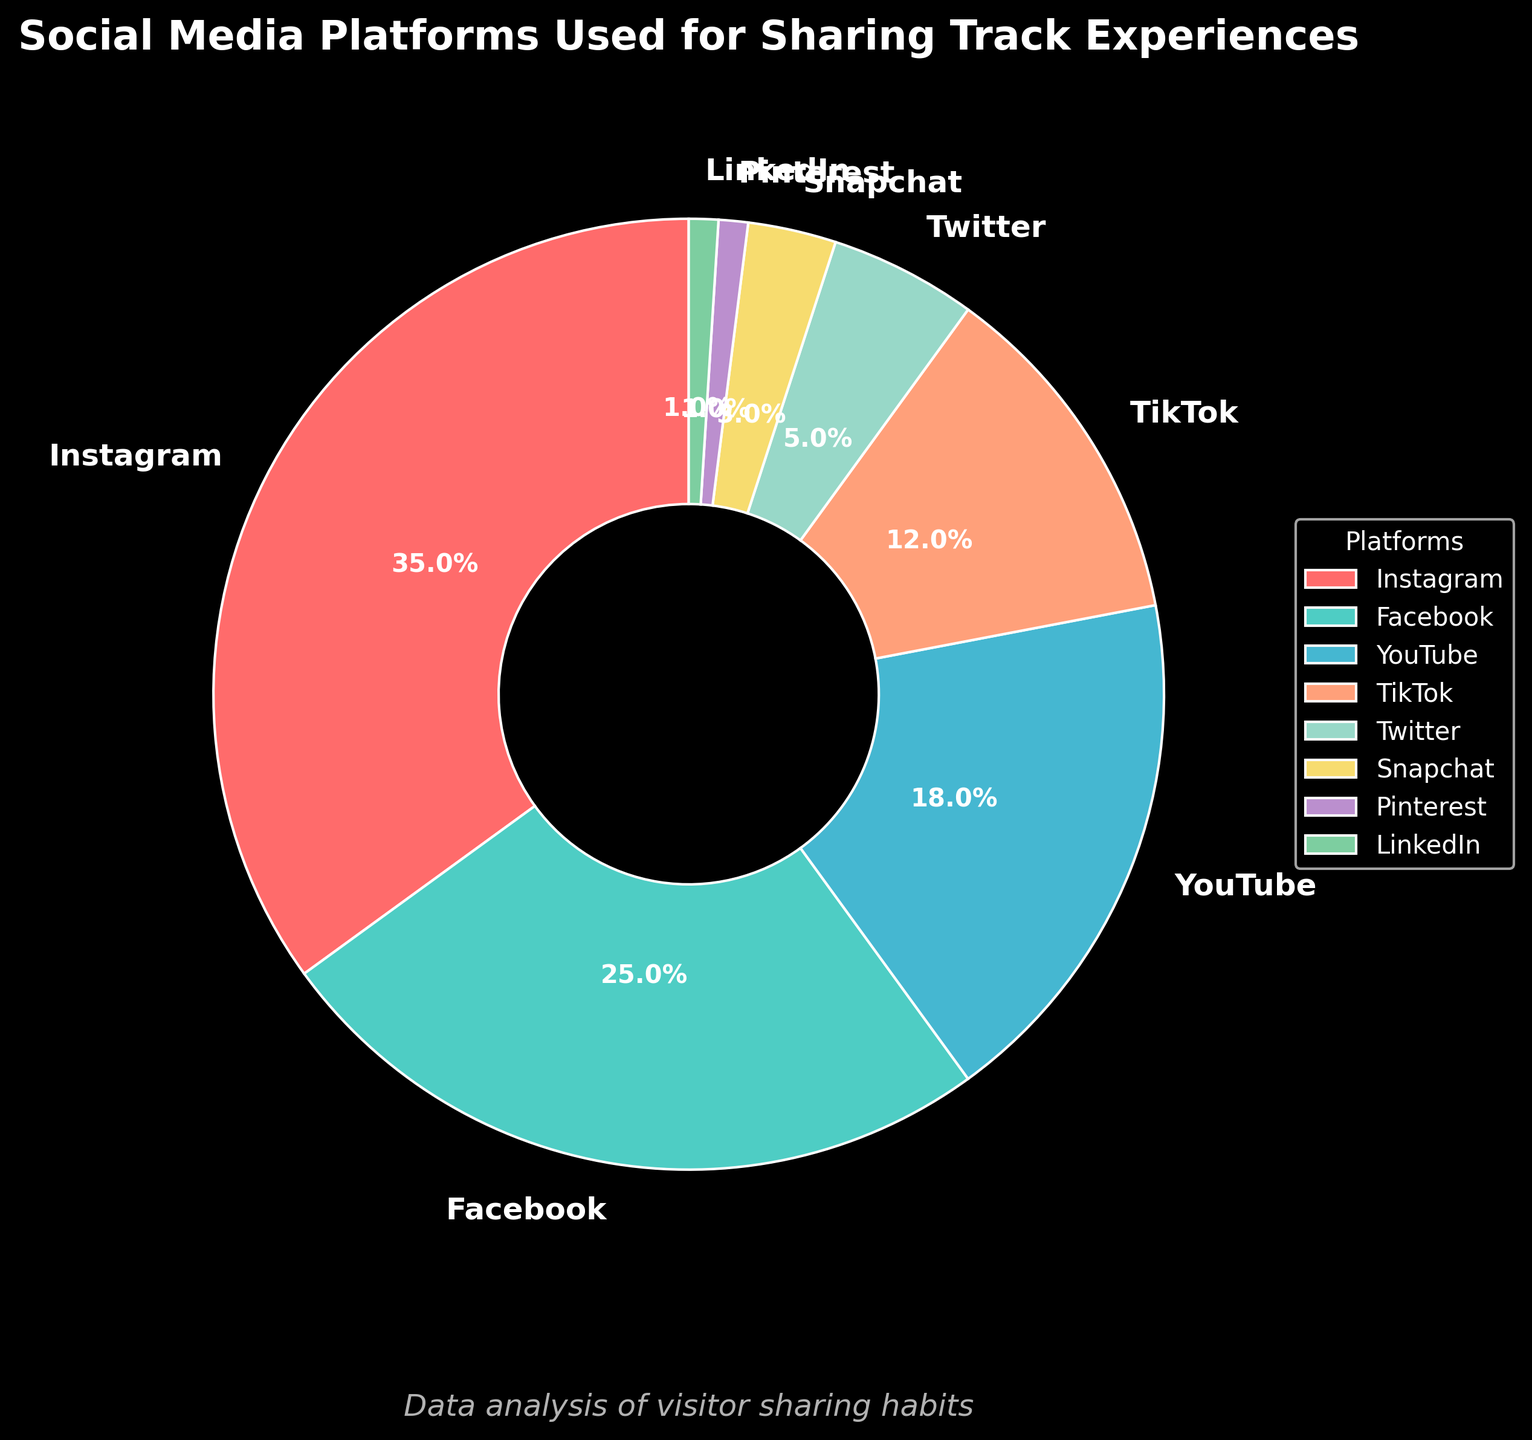Which social media platform has the largest percentage of users sharing their track experiences? The pie chart shows that Instagram has the largest slice, occupying 35% of the chart, indicating the highest percentage of users.
Answer: Instagram What is the total percentage of users who share their track experiences on YouTube and TikTok combined? According to the chart, YouTube comprises 18% and TikTok 12%. Adding these two gives 18% + 12% = 30%.
Answer: 30% How does the percentage of Instagram users compare to the percentage of Facebook users? Instagram has a 35% share, while Facebook has a 25% share. Comparing these, Instagram's percentage is 10% higher than Facebook's.
Answer: 10% higher Which social media platform has the smallest percentage of users sharing their track experiences? The smallest slice in the pie chart is for both LinkedIn and Pinterest, each with a 1% share.
Answer: LinkedIn and Pinterest What percentage of users share their experiences on platforms other than Instagram? Subtracting Instagram's 35% from 100%, the remaining percentage is 100% - 35% = 65%.
Answer: 65% How many platforms have a share greater than 10%? Examining the pie chart, Instagram (35%), Facebook (25%), YouTube (18%), and TikTok (12%) all have shares greater than 10%. That counts to four platforms.
Answer: 4 Compare the combined share of Snapchat and Twitter with that of Facebook. Which is greater? Snapchat has 3% and Twitter has 5%, together making 8%. Facebook has 25%. Therefore, Facebook's share is greater.
Answer: Facebook's share is greater What is the difference in percentage between the top platform (Instagram) and the second highest platform (Facebook)? Instagram has 35% and Facebook has 25%. The difference in percentage is 35% - 25% = 10%.
Answer: 10% Which platform, among Twitter and LinkedIn, has a larger percentage, and by how much? Twitter has 5% and LinkedIn has 1%. Twitter's percentage is larger by 5% - 1% = 4%.
Answer: Twitter by 4% Is the combined percentage of Pinterest and LinkedIn greater than Snapchat alone? Pinterest and LinkedIn each have 1%, combining to 2%. Snapchat alone has 3%. Hence, Snapchat's percentage is greater.
Answer: No, Snapchat's percentage is greater 